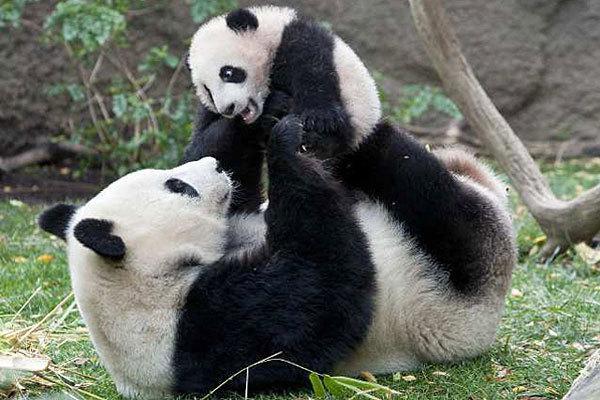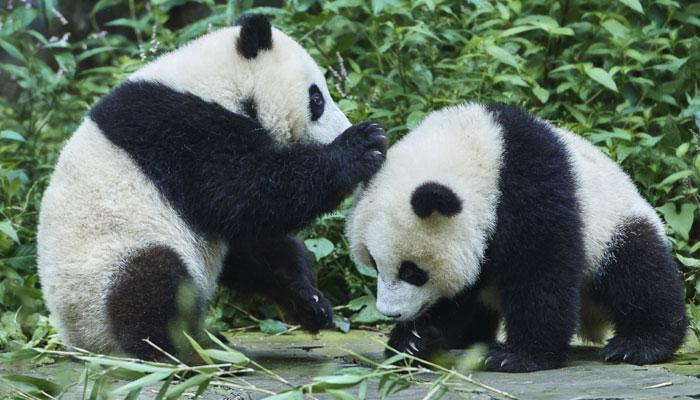The first image is the image on the left, the second image is the image on the right. For the images shown, is this caption "There are four pandas" true? Answer yes or no. Yes. The first image is the image on the left, the second image is the image on the right. For the images shown, is this caption "One image shows two pandas, and the one on the left is standing on a log platform with an arm around the back-turned panda on the right." true? Answer yes or no. No. 